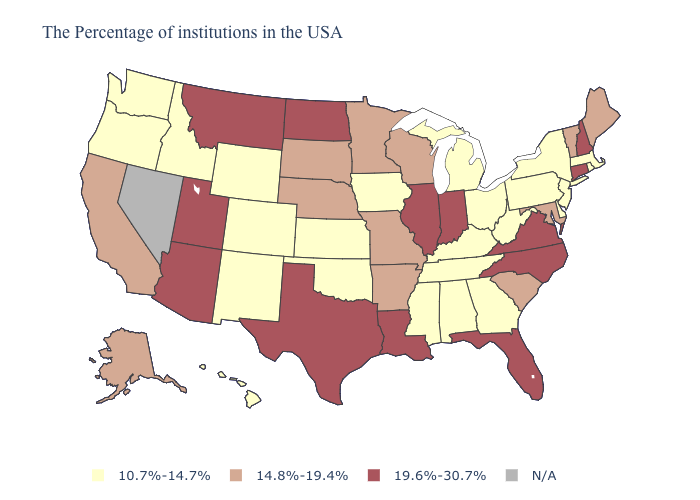Name the states that have a value in the range N/A?
Quick response, please. Nevada. Name the states that have a value in the range 14.8%-19.4%?
Give a very brief answer. Maine, Vermont, Maryland, South Carolina, Wisconsin, Missouri, Arkansas, Minnesota, Nebraska, South Dakota, California, Alaska. Does Oregon have the lowest value in the West?
Short answer required. Yes. Does Vermont have the lowest value in the Northeast?
Concise answer only. No. Among the states that border Ohio , does Kentucky have the lowest value?
Keep it brief. Yes. What is the lowest value in the USA?
Quick response, please. 10.7%-14.7%. Among the states that border Georgia , which have the highest value?
Answer briefly. North Carolina, Florida. Does Wyoming have the highest value in the USA?
Keep it brief. No. Name the states that have a value in the range N/A?
Short answer required. Nevada. What is the value of South Carolina?
Give a very brief answer. 14.8%-19.4%. Name the states that have a value in the range 10.7%-14.7%?
Keep it brief. Massachusetts, Rhode Island, New York, New Jersey, Delaware, Pennsylvania, West Virginia, Ohio, Georgia, Michigan, Kentucky, Alabama, Tennessee, Mississippi, Iowa, Kansas, Oklahoma, Wyoming, Colorado, New Mexico, Idaho, Washington, Oregon, Hawaii. Which states have the lowest value in the USA?
Quick response, please. Massachusetts, Rhode Island, New York, New Jersey, Delaware, Pennsylvania, West Virginia, Ohio, Georgia, Michigan, Kentucky, Alabama, Tennessee, Mississippi, Iowa, Kansas, Oklahoma, Wyoming, Colorado, New Mexico, Idaho, Washington, Oregon, Hawaii. Name the states that have a value in the range 19.6%-30.7%?
Quick response, please. New Hampshire, Connecticut, Virginia, North Carolina, Florida, Indiana, Illinois, Louisiana, Texas, North Dakota, Utah, Montana, Arizona. 